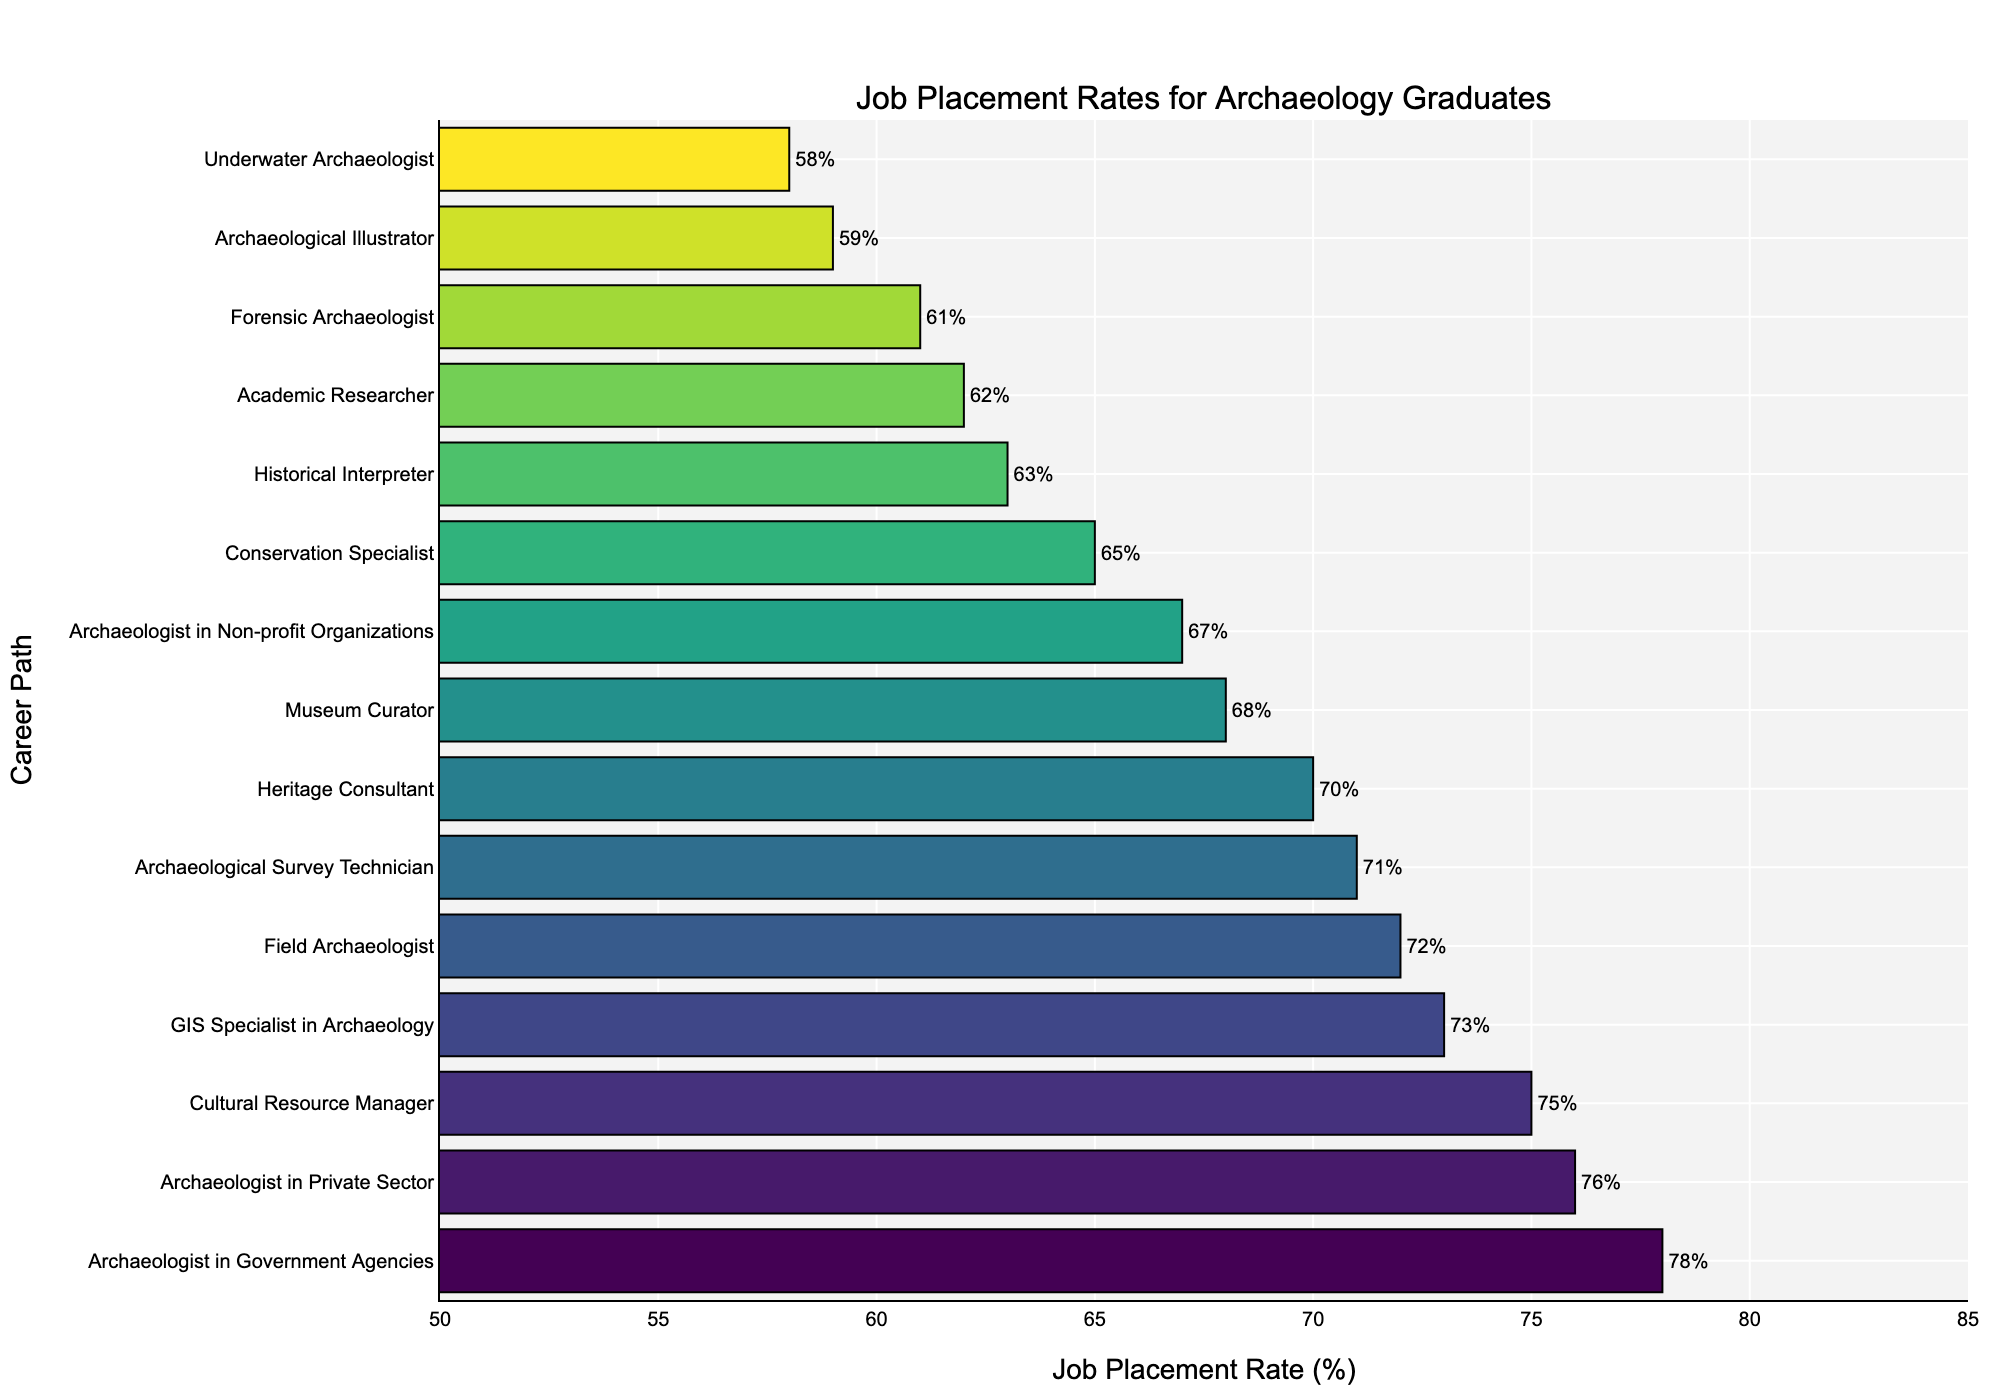What's the career path with the highest job placement rate? To find the career path with the highest job placement rate, look for the longest bar in the bar chart. The figure indicates that "Archaeologist in Government Agencies" has the highest job placement rate.
Answer: Archaeologist in Government Agencies Which two career paths have job placement rates greater than 75% but less than 80%? To find career paths with job placement rates greater than 75% but less than 80%, locate the bars with values in the range 75%-80%. The career paths "Archaeologist in Government Agencies" (78%) and "Archaeologist in Private Sector" (76%) fall within this range.
Answer: Archaeologist in Government Agencies, Archaeologist in Private Sector What is the average job placement rate of the top five career paths? Calculate the job placement rates of the top five career paths which are 78%, 76%, 75%, 73%, and 72%. The sum is 374 and dividing by 5 gives an average of 74.8%.
Answer: 74.8% Is the job placement rate for Forensic Archaeologist higher or lower compared to Historical Interpreter? Locate both career paths in the figure. Forensic Archaeologist has a job placement rate of 61%, while Historical Interpreter has 63%. Since 61% is less than 63%, Forensic Archaeologist has a lower job placement rate than Historical Interpreter.
Answer: Lower How many career paths have a job placement rate below 60%? Identify all bars with job placement rates below 60%. There are three such career paths: Archaeological Illustrator (59%), Underwater Archaeologist (58%), and Forensic Archaeologist (61%).
Answer: 3 What are the three least common job placement rates? Find the three shortest bars in the figure. The job placement rates are for Underwater Archaeologist (58%), Forensic Archaeologist (61%), and Archaeological Illustrator (59%).
Answer: 58%, 59%, 61% Is the job placement rate for GIS Specialist in Archaeology closer to that of Cultural Resource Manager or Field Archaeologist? Compare the job placement rate for GIS Specialist in Archaeology (73%) with those of Cultural Resource Manager (75%) and Field Archaeologist (72%). Since 73% is closer to 72%, GIS Specialist in Archaeology is closer to Field Archaeologist.
Answer: Field Archaeologist What career path is directly below Field Archaeologist in terms of job placement rate? Identify the job placement rate of Field Archaeologist (72%) and see the next highest rate, which is for GIS Specialist in Archaeology (73%).
Answer: GIS Specialist in Archaeology What's the total job placement rate for all career paths with placement rates above 70%? Identify all career paths above 70% job placement rate (Archaeologist in Government Agencies (78%), Archaeologist in Private Sector (76%), Cultural Resource Manager (75%), GIS Specialist in Archaeology (73%), Field Archaeologist (72%), Archaeological Survey Technician (71%), and Heritage Consultant (70%)). Sum these values: 78 + 76 + 75 + 73 + 72 + 71 + 70 = 515.
Answer: 515% What is the difference in job placement rates between Heritage Consultant and Academic Researcher? Note the job placement rates for both career paths: Heritage Consultant (70%) and Academic Researcher (62%). Subtract the smaller rate from the larger one: 70% - 62% = 8%.
Answer: 8% 